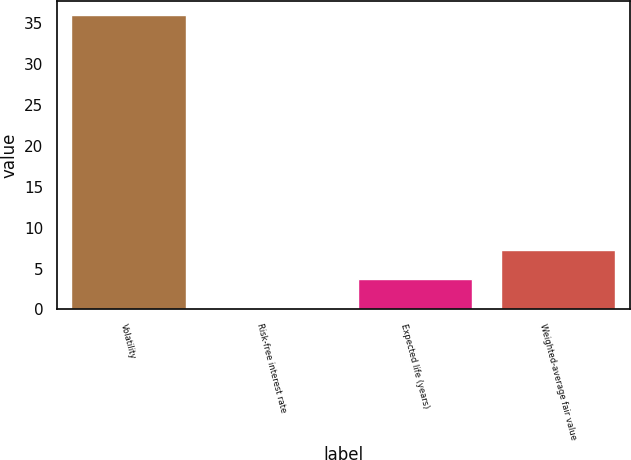Convert chart. <chart><loc_0><loc_0><loc_500><loc_500><bar_chart><fcel>Volatility<fcel>Risk-free interest rate<fcel>Expected life (years)<fcel>Weighted-average fair value<nl><fcel>36<fcel>0.1<fcel>3.69<fcel>7.28<nl></chart> 